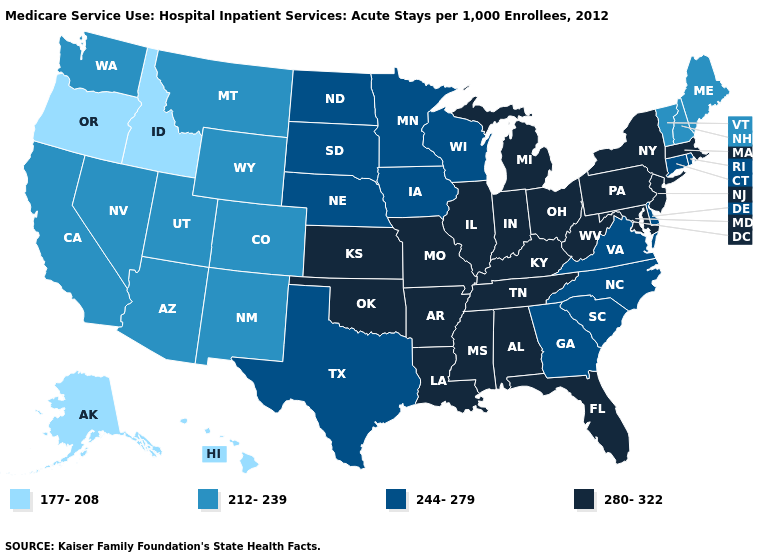Does Kansas have a higher value than Vermont?
Keep it brief. Yes. What is the value of Maryland?
Short answer required. 280-322. Name the states that have a value in the range 177-208?
Short answer required. Alaska, Hawaii, Idaho, Oregon. Does Montana have the highest value in the USA?
Keep it brief. No. Among the states that border New Jersey , which have the lowest value?
Keep it brief. Delaware. Name the states that have a value in the range 177-208?
Short answer required. Alaska, Hawaii, Idaho, Oregon. Is the legend a continuous bar?
Be succinct. No. Does the first symbol in the legend represent the smallest category?
Keep it brief. Yes. Does Washington have a lower value than Vermont?
Give a very brief answer. No. What is the value of Connecticut?
Concise answer only. 244-279. What is the value of New York?
Concise answer only. 280-322. Name the states that have a value in the range 280-322?
Answer briefly. Alabama, Arkansas, Florida, Illinois, Indiana, Kansas, Kentucky, Louisiana, Maryland, Massachusetts, Michigan, Mississippi, Missouri, New Jersey, New York, Ohio, Oklahoma, Pennsylvania, Tennessee, West Virginia. What is the lowest value in the USA?
Concise answer only. 177-208. Does Georgia have the same value as Ohio?
Concise answer only. No. 